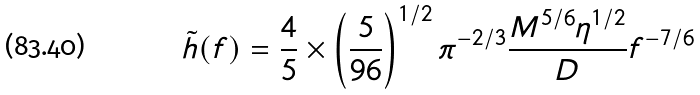<formula> <loc_0><loc_0><loc_500><loc_500>\tilde { h } ( f ) & = \frac { 4 } { 5 } \times \left ( \frac { 5 } { 9 6 } \right ) ^ { 1 / 2 } \pi ^ { - 2 / 3 } \frac { M ^ { 5 / 6 } \eta ^ { 1 / 2 } } { D } f ^ { - 7 / 6 }</formula> 